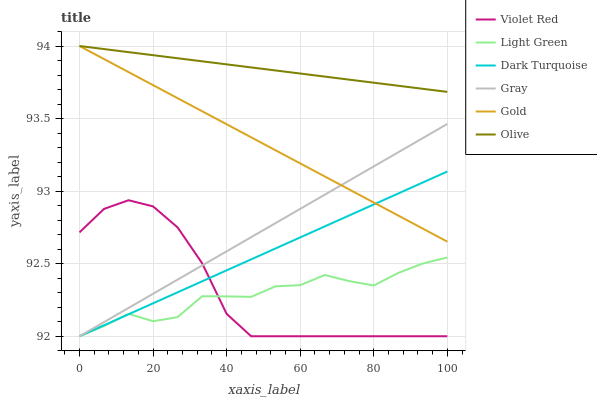Does Violet Red have the minimum area under the curve?
Answer yes or no. No. Does Violet Red have the maximum area under the curve?
Answer yes or no. No. Is Violet Red the smoothest?
Answer yes or no. No. Is Violet Red the roughest?
Answer yes or no. No. Does Gold have the lowest value?
Answer yes or no. No. Does Violet Red have the highest value?
Answer yes or no. No. Is Violet Red less than Olive?
Answer yes or no. Yes. Is Olive greater than Violet Red?
Answer yes or no. Yes. Does Violet Red intersect Olive?
Answer yes or no. No. 